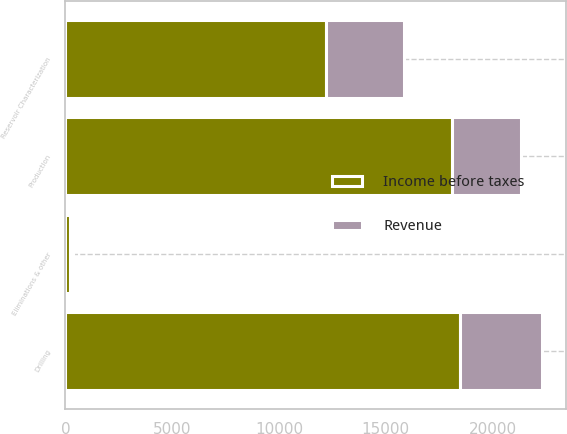<chart> <loc_0><loc_0><loc_500><loc_500><stacked_bar_chart><ecel><fcel>Reservoir Characterization<fcel>Drilling<fcel>Production<fcel>Eliminations & other<nl><fcel>Income before taxes<fcel>12224<fcel>18462<fcel>18111<fcel>217<nl><fcel>Revenue<fcel>3607<fcel>3872<fcel>3227<fcel>130<nl></chart> 